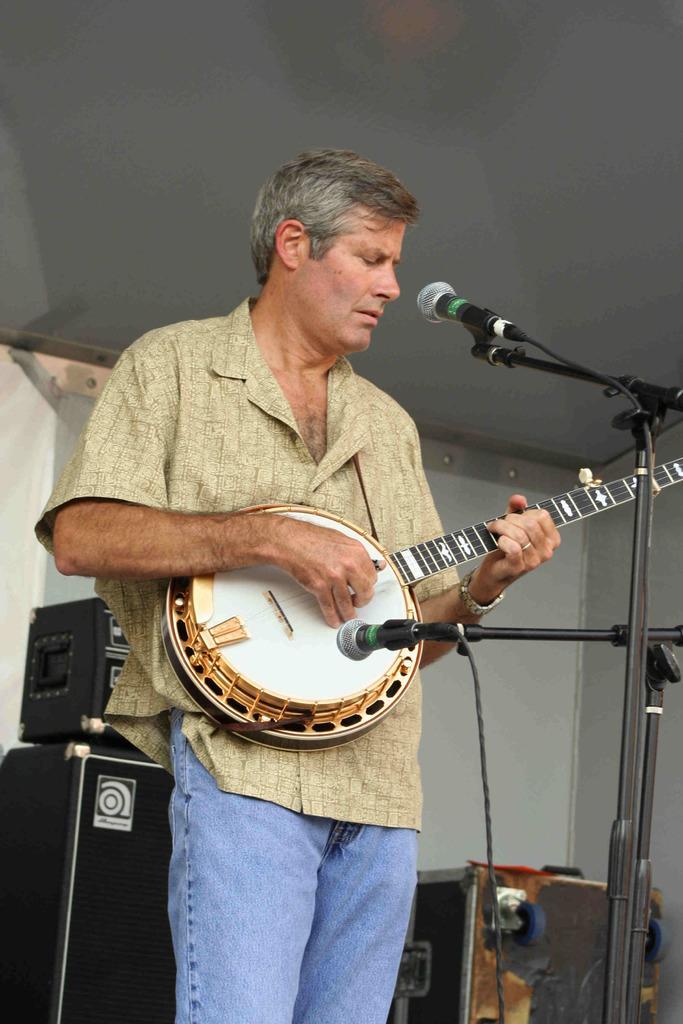How would you summarize this image in a sentence or two? In the middle of the image, there is a person in a shirt, standing, holding a guitar and playing it, in front of the mics which are attached to the stands. In the background, there are speakers, there is a roof and there is a white color surface. 